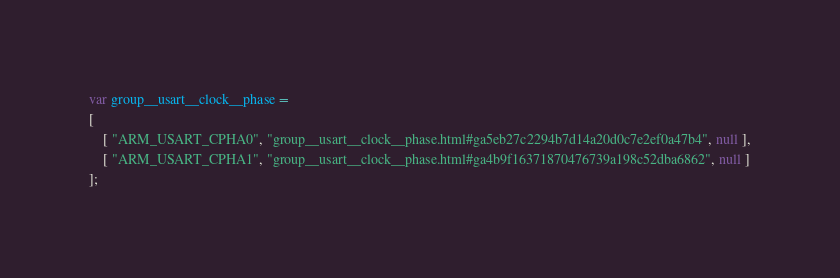Convert code to text. <code><loc_0><loc_0><loc_500><loc_500><_JavaScript_>var group__usart__clock__phase =
[
    [ "ARM_USART_CPHA0", "group__usart__clock__phase.html#ga5eb27c2294b7d14a20d0c7e2ef0a47b4", null ],
    [ "ARM_USART_CPHA1", "group__usart__clock__phase.html#ga4b9f16371870476739a198c52dba6862", null ]
];</code> 